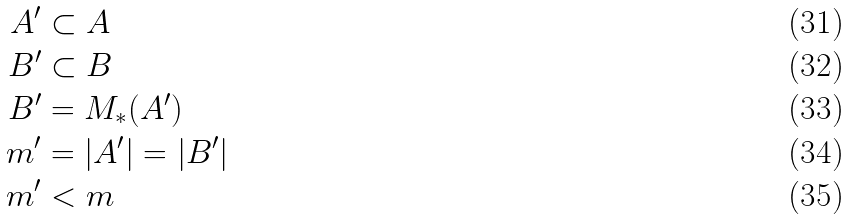Convert formula to latex. <formula><loc_0><loc_0><loc_500><loc_500>A ^ { \prime } & \subset A \\ B ^ { \prime } & \subset B \\ B ^ { \prime } & = M _ { * } ( A ^ { \prime } ) \\ m ^ { \prime } & = \left | A ^ { \prime } \right | = \left | B ^ { \prime } \right | \\ m ^ { \prime } & < m</formula> 